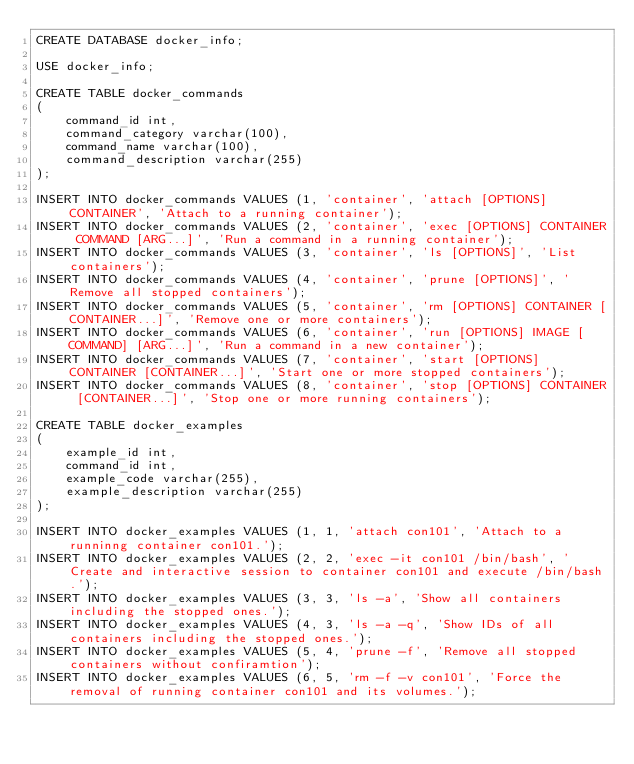<code> <loc_0><loc_0><loc_500><loc_500><_SQL_>CREATE DATABASE docker_info;

USE docker_info;

CREATE TABLE docker_commands 
(
    command_id int,
    command_category varchar(100), 
    command_name varchar(100),
    command_description varchar(255)
);

INSERT INTO docker_commands VALUES (1, 'container', 'attach [OPTIONS] CONTAINER', 'Attach to a running container');
INSERT INTO docker_commands VALUES (2, 'container', 'exec [OPTIONS] CONTAINER COMMAND [ARG...]', 'Run a command in a running container');
INSERT INTO docker_commands VALUES (3, 'container', 'ls [OPTIONS]', 'List containers');
INSERT INTO docker_commands VALUES (4, 'container', 'prune [OPTIONS]', 'Remove all stopped containers');
INSERT INTO docker_commands VALUES (5, 'container', 'rm [OPTIONS] CONTAINER [CONTAINER...]', 'Remove one or more containers');
INSERT INTO docker_commands VALUES (6, 'container', 'run [OPTIONS] IMAGE [COMMAND] [ARG...]', 'Run a command in a new container');
INSERT INTO docker_commands VALUES (7, 'container', 'start [OPTIONS] CONTAINER [CONTAINER...]', 'Start one or more stopped containers');
INSERT INTO docker_commands VALUES (8, 'container', 'stop [OPTIONS] CONTAINER [CONTAINER...]', 'Stop one or more running containers');

CREATE TABLE docker_examples 
(
    example_id int,
    command_id int,
    example_code varchar(255),
    example_description varchar(255)
);

INSERT INTO docker_examples VALUES (1, 1, 'attach con101', 'Attach to a runninng container con101.');
INSERT INTO docker_examples VALUES (2, 2, 'exec -it con101 /bin/bash', 'Create and interactive session to container con101 and execute /bin/bash.');
INSERT INTO docker_examples VALUES (3, 3, 'ls -a', 'Show all containers including the stopped ones.');
INSERT INTO docker_examples VALUES (4, 3, 'ls -a -q', 'Show IDs of all containers including the stopped ones.');
INSERT INTO docker_examples VALUES (5, 4, 'prune -f', 'Remove all stopped containers without confiramtion');
INSERT INTO docker_examples VALUES (6, 5, 'rm -f -v con101', 'Force the removal of running container con101 and its volumes.');</code> 